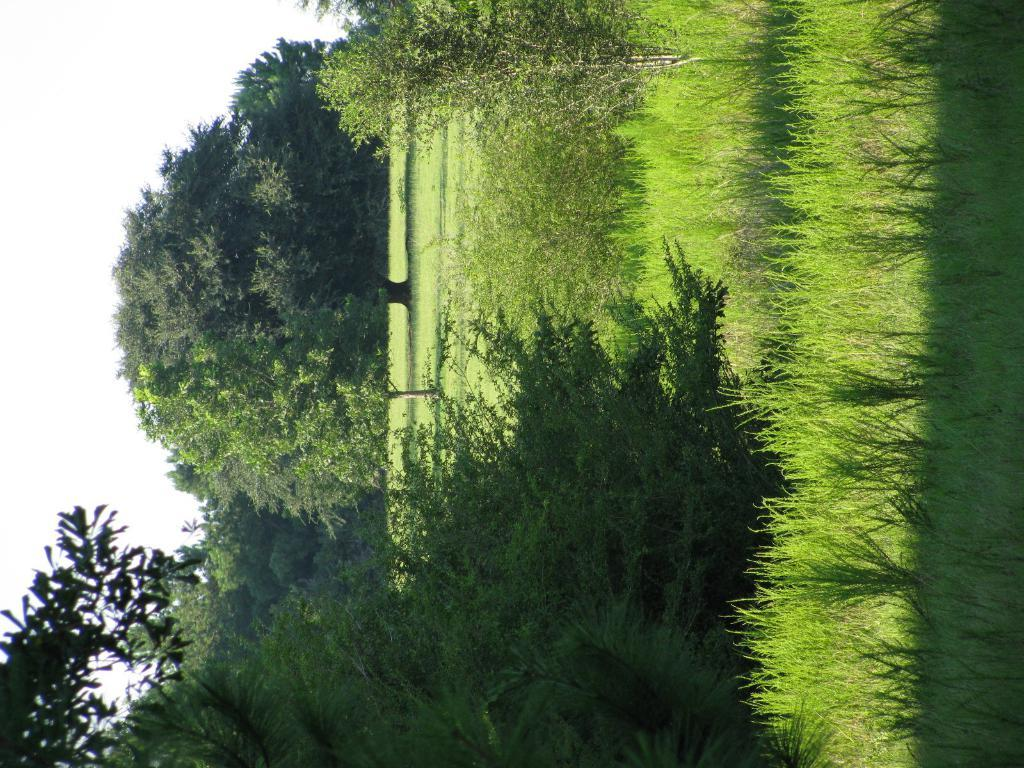What type of vegetation can be seen in the image? There are trees, plants, and grass in the image. What part of the natural environment is visible in the image? The sky is visible in the image. What type of joke is the toad telling the cat in the image? There is no toad or cat present in the image, and therefore no such interaction can be observed. 